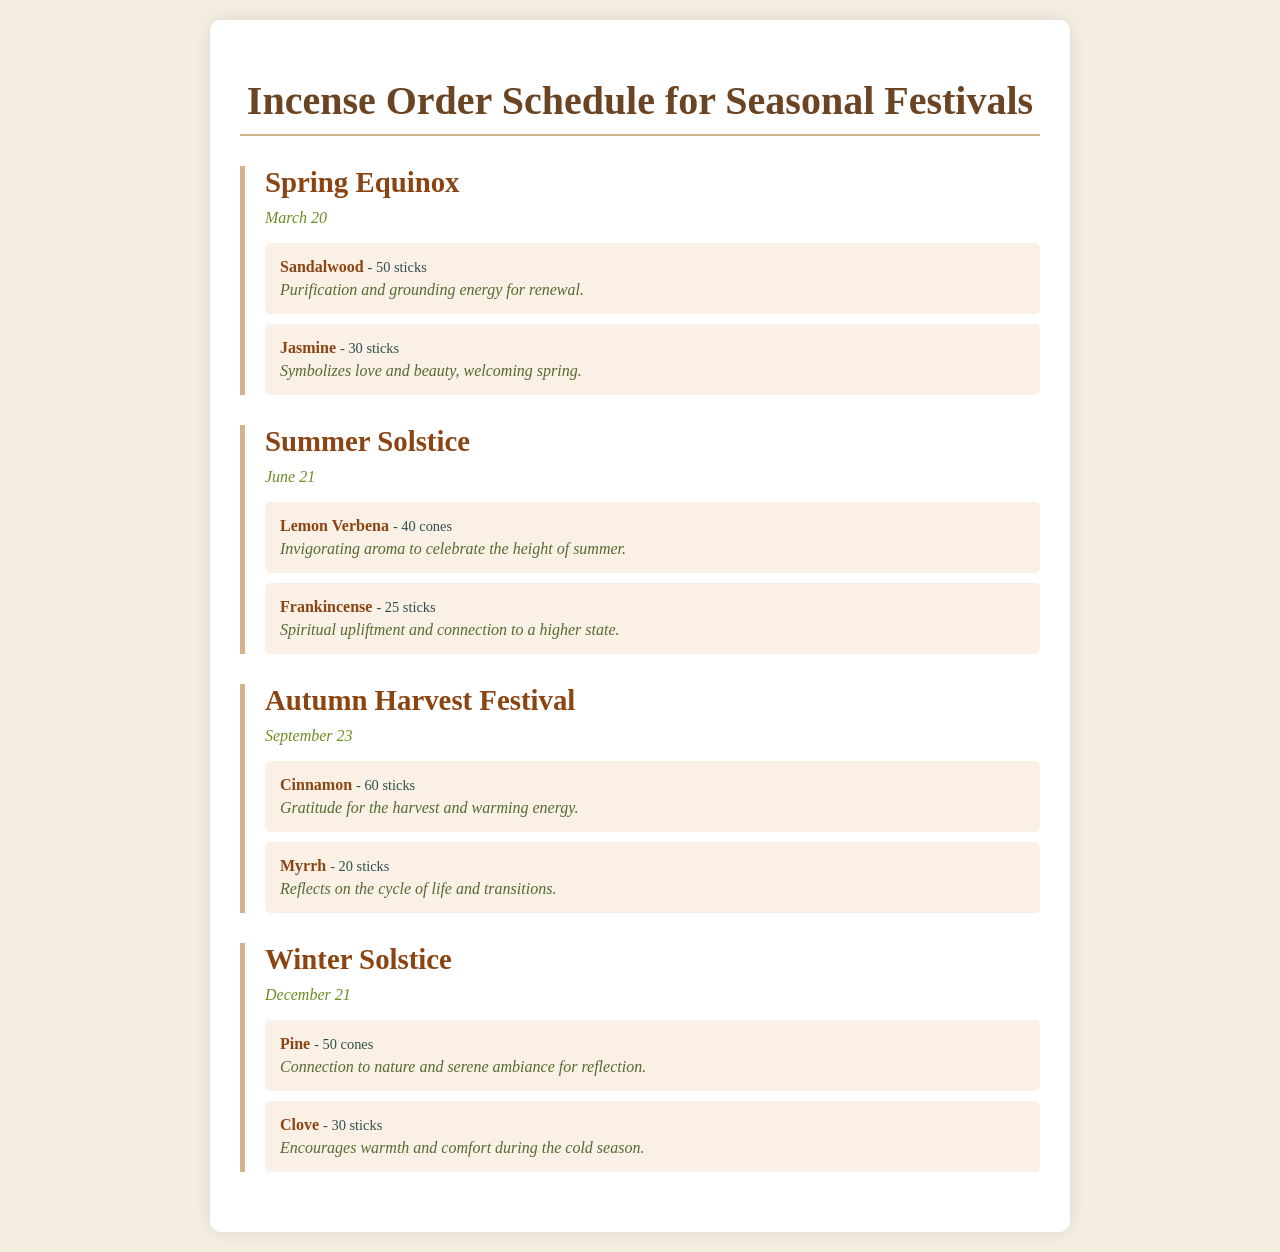What incense is used for purification during the Spring Equinox? The document lists Sandalwood as the incense used for purification during the Spring Equinox.
Answer: Sandalwood How many sticks of Jasmine incense are ordered for the Spring Equinox? The document specifies that 30 sticks of Jasmine incense are ordered for the Spring Equinox.
Answer: 30 sticks What aroma is associated with the Summer Solstice? The document mentions Lemon Verbena as the invigorating aroma for the Summer Solstice.
Answer: Lemon Verbena What is the purpose of Myrrh for the Autumn Harvest Festival? The document states that Myrrh reflects on the cycle of life and transitions during the Autumn Harvest Festival.
Answer: Reflects on the cycle of life and transitions Which festival occurs on December 21? The document indicates that the Winter Solstice festival occurs on December 21.
Answer: Winter Solstice What is the total quantity of Clove sticks ordered for the Winter Solstice? The document shows that 30 sticks of Clove incense are ordered for the Winter Solstice.
Answer: 30 sticks Which two incenses are specified for the Autumn Harvest Festival? The document lists Cinnamon and Myrrh as the two incenses for the Autumn Harvest Festival.
Answer: Cinnamon and Myrrh How many cones of Pine are ordered for the Winter Solstice? The document notes that 50 cones of Pine incense are ordered for the Winter Solstice.
Answer: 50 cones 